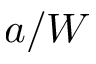Convert formula to latex. <formula><loc_0><loc_0><loc_500><loc_500>a / W</formula> 